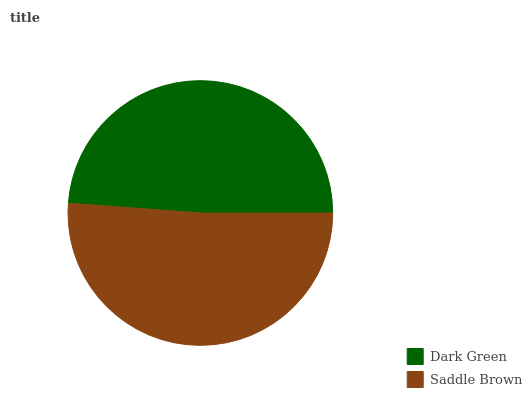Is Dark Green the minimum?
Answer yes or no. Yes. Is Saddle Brown the maximum?
Answer yes or no. Yes. Is Saddle Brown the minimum?
Answer yes or no. No. Is Saddle Brown greater than Dark Green?
Answer yes or no. Yes. Is Dark Green less than Saddle Brown?
Answer yes or no. Yes. Is Dark Green greater than Saddle Brown?
Answer yes or no. No. Is Saddle Brown less than Dark Green?
Answer yes or no. No. Is Saddle Brown the high median?
Answer yes or no. Yes. Is Dark Green the low median?
Answer yes or no. Yes. Is Dark Green the high median?
Answer yes or no. No. Is Saddle Brown the low median?
Answer yes or no. No. 